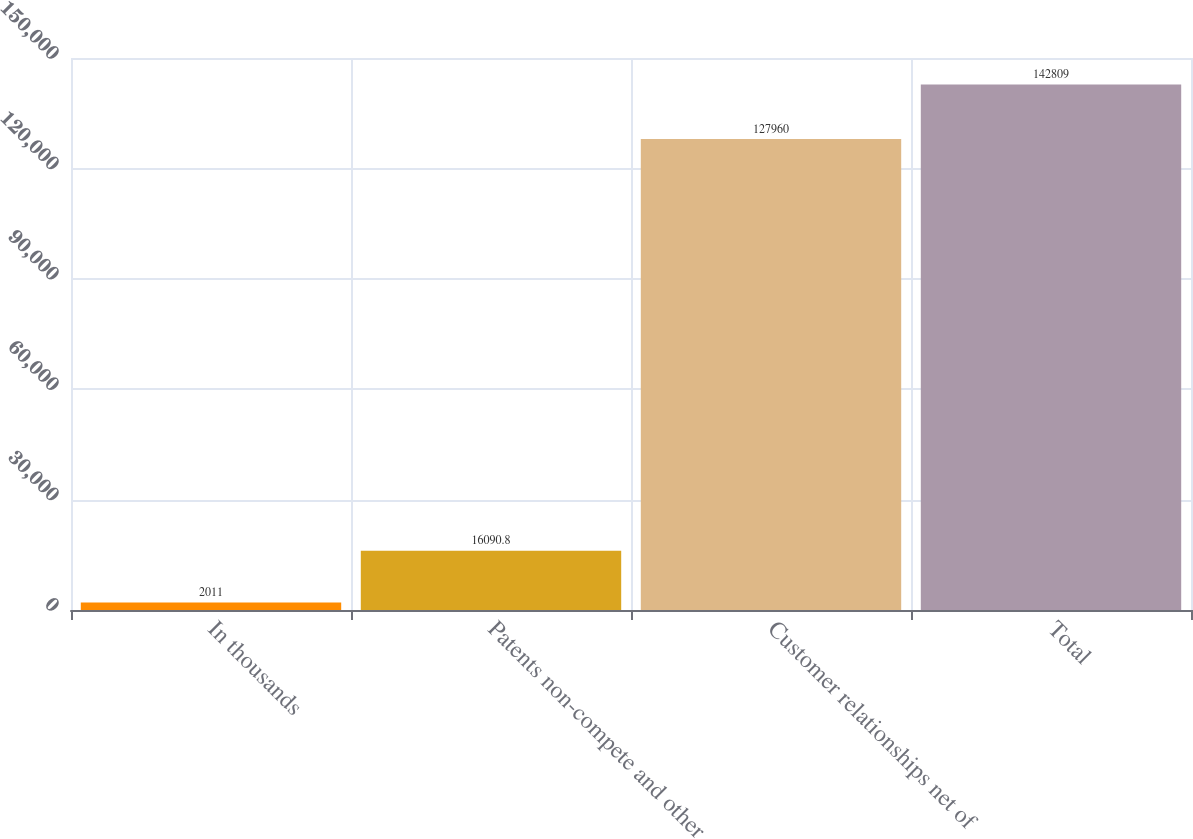Convert chart to OTSL. <chart><loc_0><loc_0><loc_500><loc_500><bar_chart><fcel>In thousands<fcel>Patents non-compete and other<fcel>Customer relationships net of<fcel>Total<nl><fcel>2011<fcel>16090.8<fcel>127960<fcel>142809<nl></chart> 